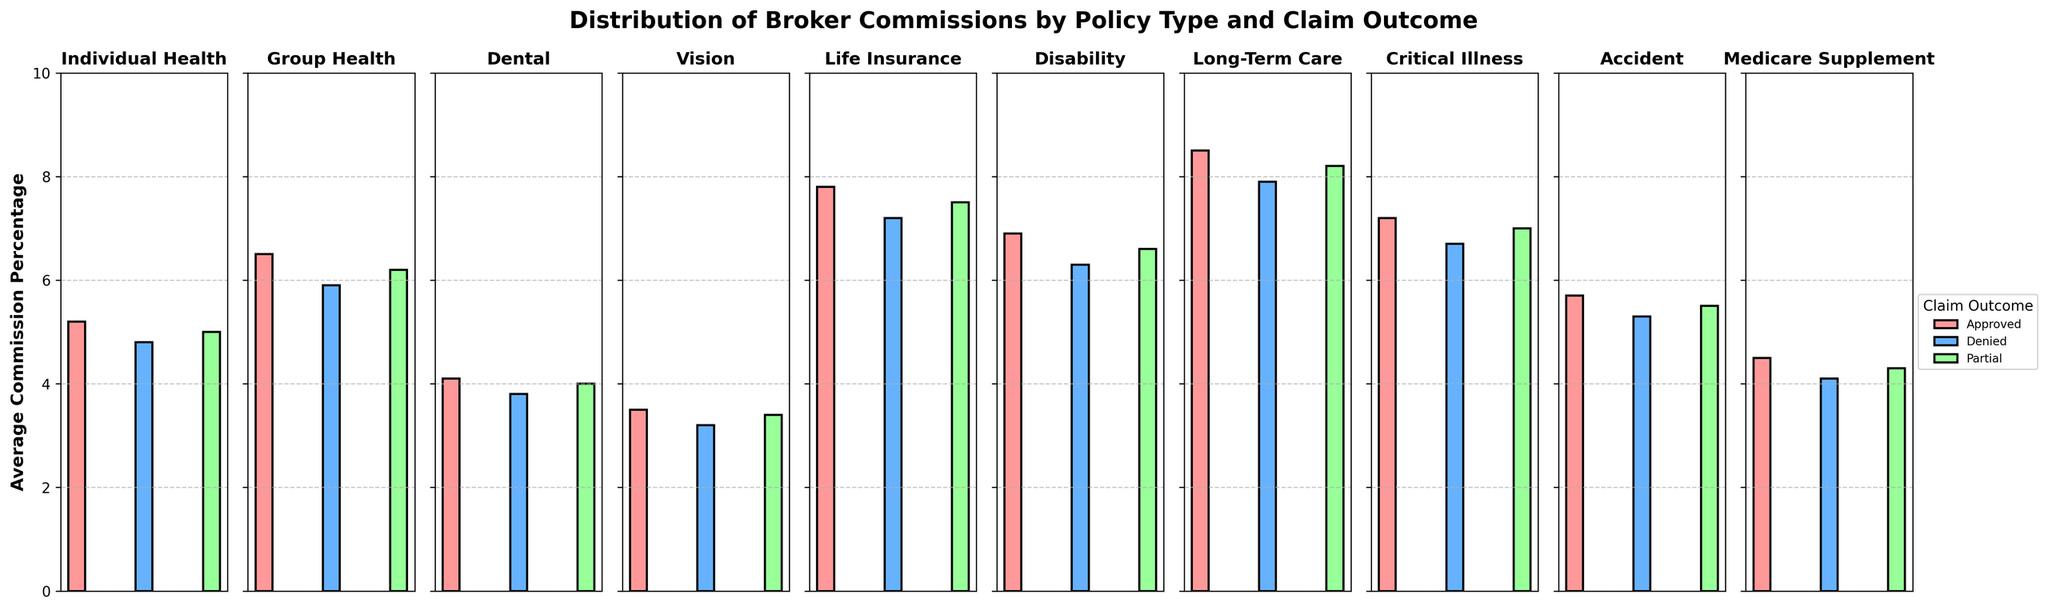What is the average commission percentage for 'Individual Health' policies with an 'Approved' claim outcome? To find the average commission percentage for 'Individual Health' policies with an 'Approved' claim outcome, locate the corresponding bar under the 'Individual Health' subplot with the color representing 'Approved'.
Answer: 5.2 Which policy type has the lowest average commission percentage for 'Denied' claims? To determine which policy type has the lowest average commission percentage for 'Denied' claims, locate the bars for 'Denied' claims in all subplots and compare their heights. The policy type with the shortest bar for 'Denied' claims is the lowest.
Answer: Vision Which policy type has the highest average commission percentage for 'Approved' claims? For this, look at the 'Approved' claims bars in each subplot, then compare their heights. The tallest bar under 'Approved' claims represents the highest average commission percentage.
Answer: Long-Term Care How much higher is the average commission percentage for 'Group Health' policies with a 'Partial' claim outcome compared to 'Denied' claim outcome? First, find the average commission percentages for 'Partial' and 'Denied' claim outcomes under the 'Group Health' subplot. Subtract the 'Denied' percentage from the 'Partial' percentage to get the difference.
Answer: 0.3 Which claim outcome generally has higher average commission percentages in 'Life Insurance' compared to 'Medicare Supplement'? Compare all three claim outcomes’ bars in the 'Life Insurance' subplot against their counterparts in the 'Medicare Supplement' subplot. Identify which claim outcomes in 'Life Insurance' have consistently higher bars.
Answer: All claim outcomes (Approved, Denied, Partial) What is the combined average commission percentage for 'Disability' policies for 'Approved' and 'Denied' claim outcomes? Sum the heights of the bars for 'Approved' and 'Denied' claim outcomes in the 'Disability' subplot. The combined average commission percentage is their total.
Answer: 13.2 Compare the average commission percentage for 'Critical Illness' policies with 'Partial' and 'Denied' claim outcomes. Which one is higher? Look at the 'Partial' and 'Denied' bars in the 'Critical Illness' subplot. Determine which bar is taller.
Answer: Partial By how much does the average commission percentage for 'Long-Term Care' policies for 'Approved' claims exceed the average for 'Dental' policies with 'Approved' claims? Find the average commission percentages for 'Approved' claims in both the 'Long-Term Care' and 'Dental' subplots. Subtract the 'Dental' percentage from the 'Long-Term Care' percentage to calculate the excess amount.
Answer: 4.4 Which policy type shows the smallest difference in average commission percentages between 'Approved' and 'Partial' claim outcomes? Calculate the difference between the 'Approved' and 'Partial' bars' heights in each subplot. The policy type with the smallest difference represents the answer.
Answer: Vision 